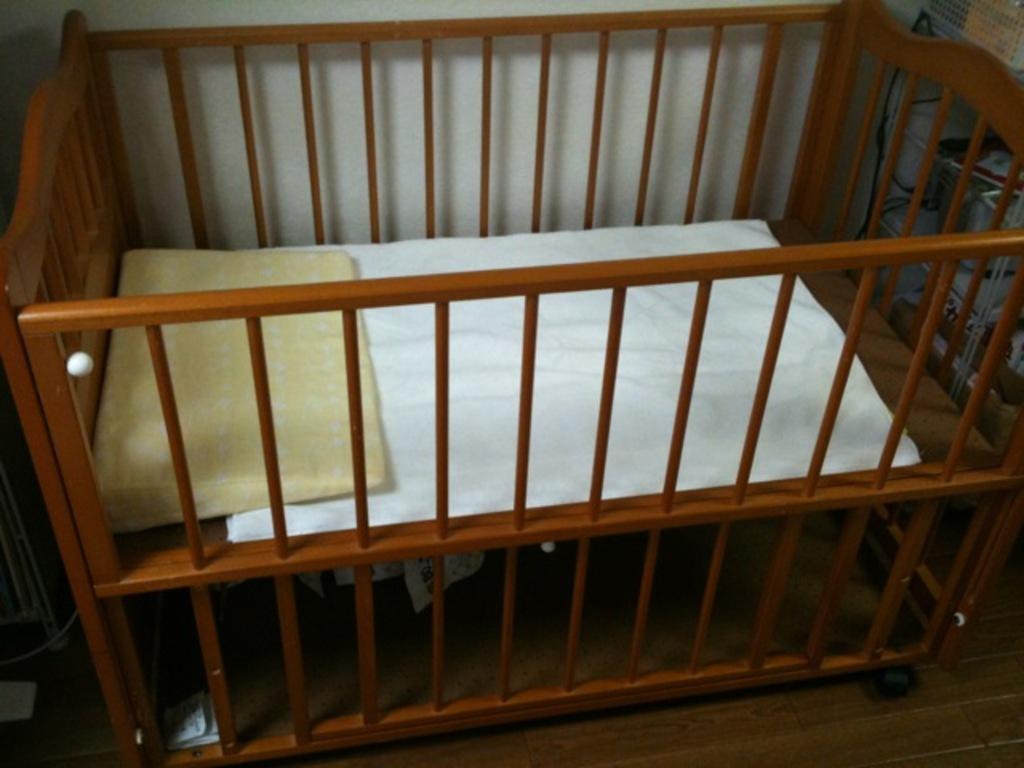Describe this image in one or two sentences. In this image, I can see a pillow and a cloth in an infant bed, which is on the floor. In the background, there is a wall. On the right side of the image, I can see few objects. 